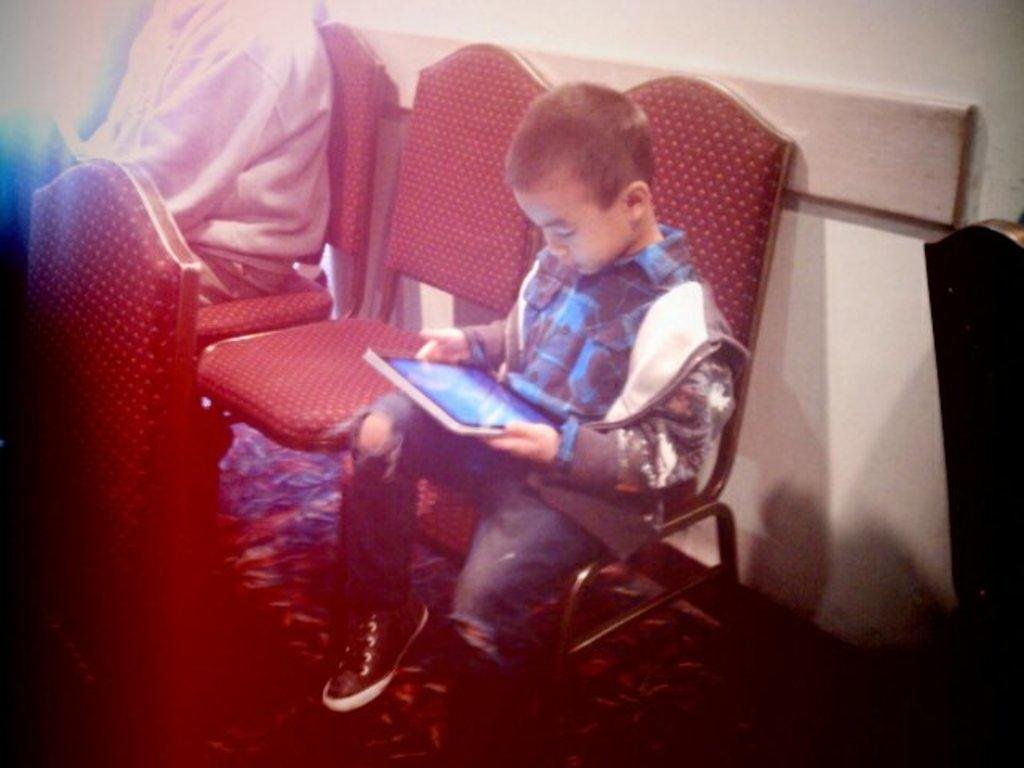What is the color of the wall in the image? The wall in the image is white. What are the two people in the image doing? The two people are sitting on chairs in the image. Can you describe one of the individuals in the image? One of the individuals is a boy. What is the boy holding in the image? The boy is holding a tablet. How many giants can be seen in the image? There are no giants present in the image. What type of division is being performed by the team in the image? There is no team or division activity present in the image. 